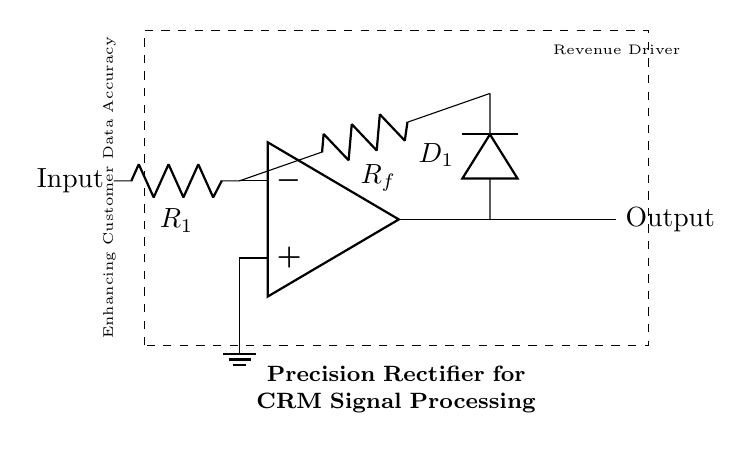What is the input component in the circuit? The input is represented by the component labeled "Input" on the left side of the op-amp, connected to the negative terminal of the op-amp.
Answer: Input What type of circuit is depicted here? The circuit is identified as a precision rectifier circuit, as indicated by the labeling within the dashed rectangle.
Answer: Precision rectifier How many resistors are present in the circuit? There are two resistors shown in the circuit: one labeled R_1 connected to the input and another labeled R_f connected to the feedback loop.
Answer: 2 What is the role of the diode in this circuit? The diode D_1 allows current to pass predominantly in one direction, enabling the rectification process needed for accurate signal processing in this precision rectifier.
Answer: Rectification Explain why a precision rectifier is used instead of a standard rectifier. A precision rectifier is employed here because it allows for accurate processing of small signals, which is crucial in customer relationship management systems that require high data fidelity. Standard rectifiers may not provide the same level of accuracy for low voltage signals.
Answer: Accurate processing What is the output characteristic of this circuit? The output is characterized as a rectified version of the input signal, enhancing the signal for further processing in CRM software. The circuit is designed to produce an output voltage reflecting only the positive part of the input waveform.
Answer: Rectified voltage What is emphasized by the text "Enhancing Customer Data Accuracy"? This phrase highlights the importance of the precision rectifier circuit in ensuring that the signals processed for CRM applications are accurate, indicating its role in data integrity paramount for decision making and revenue generation.
Answer: Data accuracy 